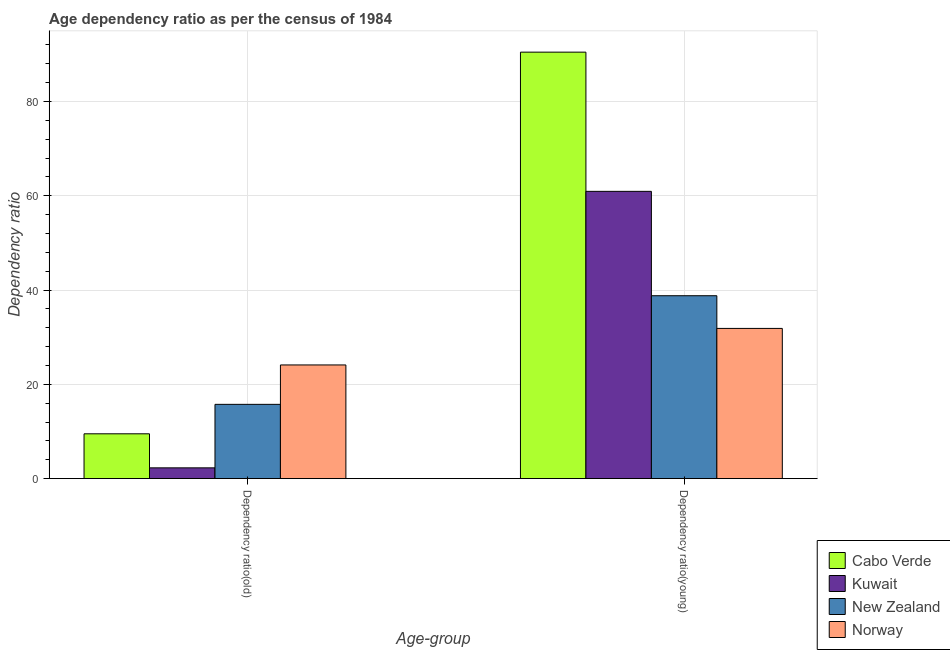How many groups of bars are there?
Offer a terse response. 2. How many bars are there on the 2nd tick from the right?
Give a very brief answer. 4. What is the label of the 1st group of bars from the left?
Your answer should be compact. Dependency ratio(old). What is the age dependency ratio(young) in Kuwait?
Your answer should be very brief. 60.94. Across all countries, what is the maximum age dependency ratio(old)?
Provide a short and direct response. 24.11. Across all countries, what is the minimum age dependency ratio(old)?
Make the answer very short. 2.28. In which country was the age dependency ratio(young) maximum?
Your answer should be very brief. Cabo Verde. In which country was the age dependency ratio(young) minimum?
Your answer should be very brief. Norway. What is the total age dependency ratio(old) in the graph?
Provide a succinct answer. 51.66. What is the difference between the age dependency ratio(old) in Kuwait and that in New Zealand?
Provide a succinct answer. -13.47. What is the difference between the age dependency ratio(young) in New Zealand and the age dependency ratio(old) in Kuwait?
Offer a terse response. 36.52. What is the average age dependency ratio(young) per country?
Offer a very short reply. 55.52. What is the difference between the age dependency ratio(young) and age dependency ratio(old) in Cabo Verde?
Provide a short and direct response. 80.97. In how many countries, is the age dependency ratio(young) greater than 76 ?
Offer a terse response. 1. What is the ratio of the age dependency ratio(young) in Kuwait to that in Norway?
Provide a succinct answer. 1.91. Is the age dependency ratio(old) in Norway less than that in Cabo Verde?
Ensure brevity in your answer.  No. In how many countries, is the age dependency ratio(young) greater than the average age dependency ratio(young) taken over all countries?
Offer a terse response. 2. What does the 2nd bar from the left in Dependency ratio(old) represents?
Your answer should be compact. Kuwait. What does the 3rd bar from the right in Dependency ratio(old) represents?
Offer a very short reply. Kuwait. How many bars are there?
Provide a succinct answer. 8. Are all the bars in the graph horizontal?
Provide a succinct answer. No. What is the difference between two consecutive major ticks on the Y-axis?
Offer a terse response. 20. Are the values on the major ticks of Y-axis written in scientific E-notation?
Provide a succinct answer. No. Does the graph contain any zero values?
Your answer should be compact. No. Does the graph contain grids?
Your answer should be compact. Yes. How many legend labels are there?
Your answer should be compact. 4. What is the title of the graph?
Offer a very short reply. Age dependency ratio as per the census of 1984. What is the label or title of the X-axis?
Offer a very short reply. Age-group. What is the label or title of the Y-axis?
Make the answer very short. Dependency ratio. What is the Dependency ratio in Cabo Verde in Dependency ratio(old)?
Offer a terse response. 9.51. What is the Dependency ratio in Kuwait in Dependency ratio(old)?
Offer a terse response. 2.28. What is the Dependency ratio in New Zealand in Dependency ratio(old)?
Your response must be concise. 15.76. What is the Dependency ratio in Norway in Dependency ratio(old)?
Provide a short and direct response. 24.11. What is the Dependency ratio of Cabo Verde in Dependency ratio(young)?
Give a very brief answer. 90.48. What is the Dependency ratio of Kuwait in Dependency ratio(young)?
Ensure brevity in your answer.  60.94. What is the Dependency ratio in New Zealand in Dependency ratio(young)?
Keep it short and to the point. 38.8. What is the Dependency ratio in Norway in Dependency ratio(young)?
Keep it short and to the point. 31.86. Across all Age-group, what is the maximum Dependency ratio in Cabo Verde?
Your answer should be very brief. 90.48. Across all Age-group, what is the maximum Dependency ratio of Kuwait?
Make the answer very short. 60.94. Across all Age-group, what is the maximum Dependency ratio of New Zealand?
Offer a very short reply. 38.8. Across all Age-group, what is the maximum Dependency ratio of Norway?
Provide a short and direct response. 31.86. Across all Age-group, what is the minimum Dependency ratio of Cabo Verde?
Make the answer very short. 9.51. Across all Age-group, what is the minimum Dependency ratio in Kuwait?
Keep it short and to the point. 2.28. Across all Age-group, what is the minimum Dependency ratio in New Zealand?
Offer a terse response. 15.76. Across all Age-group, what is the minimum Dependency ratio of Norway?
Provide a short and direct response. 24.11. What is the total Dependency ratio of Cabo Verde in the graph?
Offer a very short reply. 99.98. What is the total Dependency ratio in Kuwait in the graph?
Provide a succinct answer. 63.23. What is the total Dependency ratio in New Zealand in the graph?
Give a very brief answer. 54.56. What is the total Dependency ratio of Norway in the graph?
Your response must be concise. 55.98. What is the difference between the Dependency ratio of Cabo Verde in Dependency ratio(old) and that in Dependency ratio(young)?
Give a very brief answer. -80.97. What is the difference between the Dependency ratio of Kuwait in Dependency ratio(old) and that in Dependency ratio(young)?
Make the answer very short. -58.66. What is the difference between the Dependency ratio in New Zealand in Dependency ratio(old) and that in Dependency ratio(young)?
Provide a short and direct response. -23.05. What is the difference between the Dependency ratio of Norway in Dependency ratio(old) and that in Dependency ratio(young)?
Provide a short and direct response. -7.75. What is the difference between the Dependency ratio in Cabo Verde in Dependency ratio(old) and the Dependency ratio in Kuwait in Dependency ratio(young)?
Provide a short and direct response. -51.44. What is the difference between the Dependency ratio of Cabo Verde in Dependency ratio(old) and the Dependency ratio of New Zealand in Dependency ratio(young)?
Your response must be concise. -29.29. What is the difference between the Dependency ratio in Cabo Verde in Dependency ratio(old) and the Dependency ratio in Norway in Dependency ratio(young)?
Keep it short and to the point. -22.36. What is the difference between the Dependency ratio of Kuwait in Dependency ratio(old) and the Dependency ratio of New Zealand in Dependency ratio(young)?
Make the answer very short. -36.52. What is the difference between the Dependency ratio in Kuwait in Dependency ratio(old) and the Dependency ratio in Norway in Dependency ratio(young)?
Your answer should be very brief. -29.58. What is the difference between the Dependency ratio of New Zealand in Dependency ratio(old) and the Dependency ratio of Norway in Dependency ratio(young)?
Provide a succinct answer. -16.11. What is the average Dependency ratio in Cabo Verde per Age-group?
Keep it short and to the point. 49.99. What is the average Dependency ratio in Kuwait per Age-group?
Your response must be concise. 31.61. What is the average Dependency ratio in New Zealand per Age-group?
Offer a very short reply. 27.28. What is the average Dependency ratio of Norway per Age-group?
Keep it short and to the point. 27.99. What is the difference between the Dependency ratio of Cabo Verde and Dependency ratio of Kuwait in Dependency ratio(old)?
Give a very brief answer. 7.22. What is the difference between the Dependency ratio in Cabo Verde and Dependency ratio in New Zealand in Dependency ratio(old)?
Give a very brief answer. -6.25. What is the difference between the Dependency ratio of Cabo Verde and Dependency ratio of Norway in Dependency ratio(old)?
Make the answer very short. -14.61. What is the difference between the Dependency ratio of Kuwait and Dependency ratio of New Zealand in Dependency ratio(old)?
Provide a short and direct response. -13.47. What is the difference between the Dependency ratio in Kuwait and Dependency ratio in Norway in Dependency ratio(old)?
Your response must be concise. -21.83. What is the difference between the Dependency ratio of New Zealand and Dependency ratio of Norway in Dependency ratio(old)?
Make the answer very short. -8.36. What is the difference between the Dependency ratio in Cabo Verde and Dependency ratio in Kuwait in Dependency ratio(young)?
Keep it short and to the point. 29.53. What is the difference between the Dependency ratio in Cabo Verde and Dependency ratio in New Zealand in Dependency ratio(young)?
Keep it short and to the point. 51.67. What is the difference between the Dependency ratio in Cabo Verde and Dependency ratio in Norway in Dependency ratio(young)?
Provide a succinct answer. 58.61. What is the difference between the Dependency ratio of Kuwait and Dependency ratio of New Zealand in Dependency ratio(young)?
Your answer should be very brief. 22.14. What is the difference between the Dependency ratio in Kuwait and Dependency ratio in Norway in Dependency ratio(young)?
Provide a short and direct response. 29.08. What is the difference between the Dependency ratio of New Zealand and Dependency ratio of Norway in Dependency ratio(young)?
Your answer should be compact. 6.94. What is the ratio of the Dependency ratio in Cabo Verde in Dependency ratio(old) to that in Dependency ratio(young)?
Ensure brevity in your answer.  0.11. What is the ratio of the Dependency ratio in Kuwait in Dependency ratio(old) to that in Dependency ratio(young)?
Your response must be concise. 0.04. What is the ratio of the Dependency ratio in New Zealand in Dependency ratio(old) to that in Dependency ratio(young)?
Give a very brief answer. 0.41. What is the ratio of the Dependency ratio in Norway in Dependency ratio(old) to that in Dependency ratio(young)?
Your answer should be compact. 0.76. What is the difference between the highest and the second highest Dependency ratio in Cabo Verde?
Offer a very short reply. 80.97. What is the difference between the highest and the second highest Dependency ratio of Kuwait?
Offer a terse response. 58.66. What is the difference between the highest and the second highest Dependency ratio of New Zealand?
Offer a terse response. 23.05. What is the difference between the highest and the second highest Dependency ratio of Norway?
Provide a succinct answer. 7.75. What is the difference between the highest and the lowest Dependency ratio in Cabo Verde?
Make the answer very short. 80.97. What is the difference between the highest and the lowest Dependency ratio in Kuwait?
Your response must be concise. 58.66. What is the difference between the highest and the lowest Dependency ratio of New Zealand?
Provide a succinct answer. 23.05. What is the difference between the highest and the lowest Dependency ratio of Norway?
Your answer should be very brief. 7.75. 